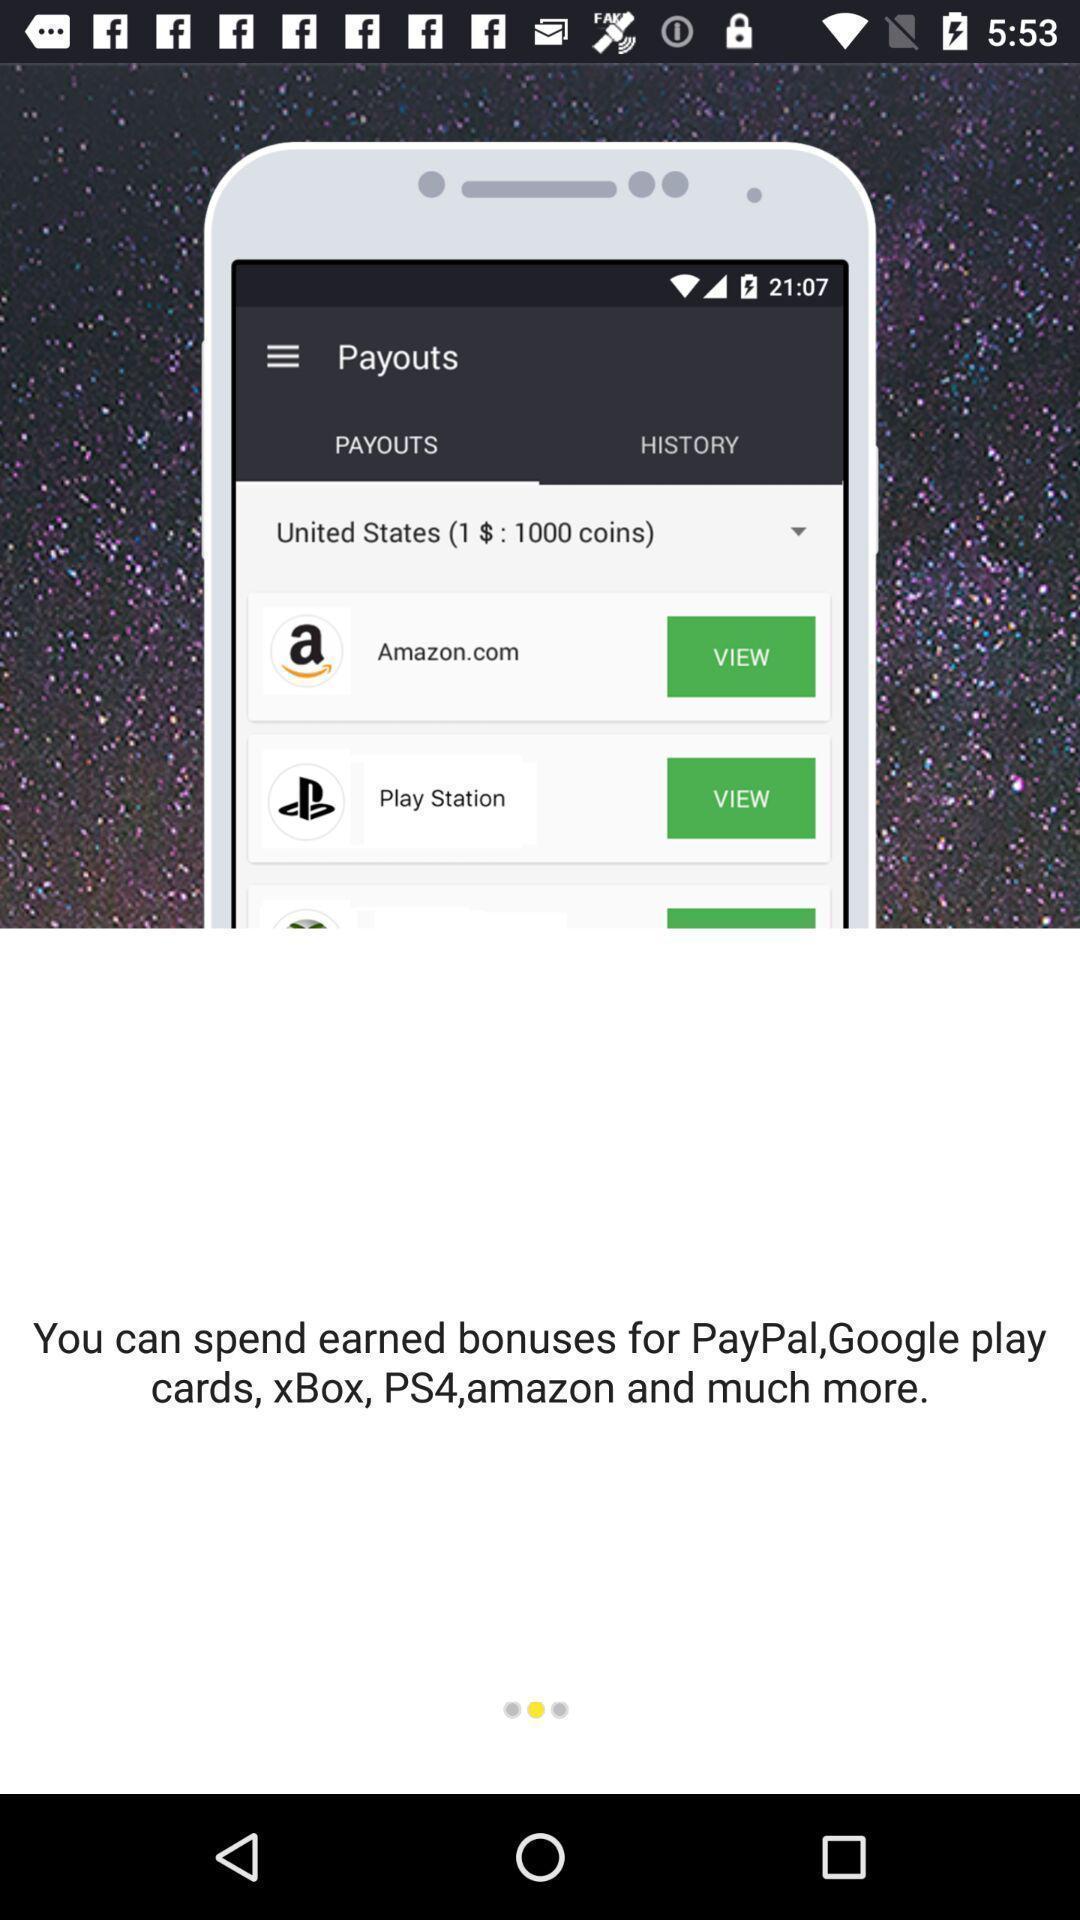Provide a textual representation of this image. Welcome page displaying. 